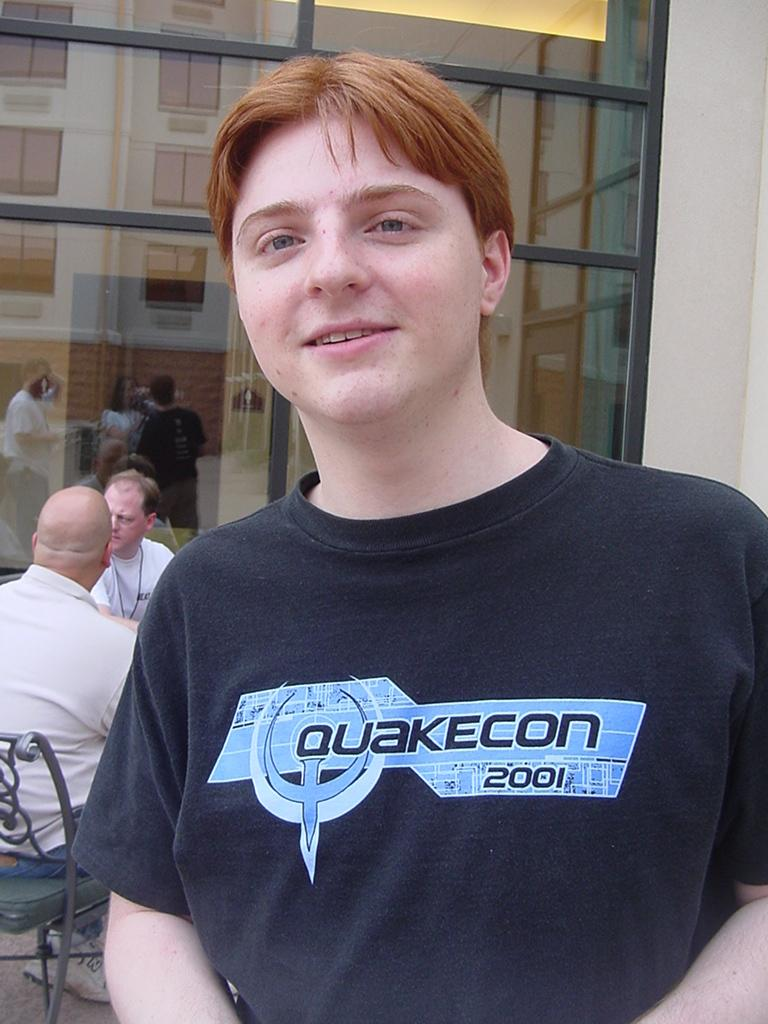<image>
Render a clear and concise summary of the photo. a red headed person in a Quakecon 2001 shirt 